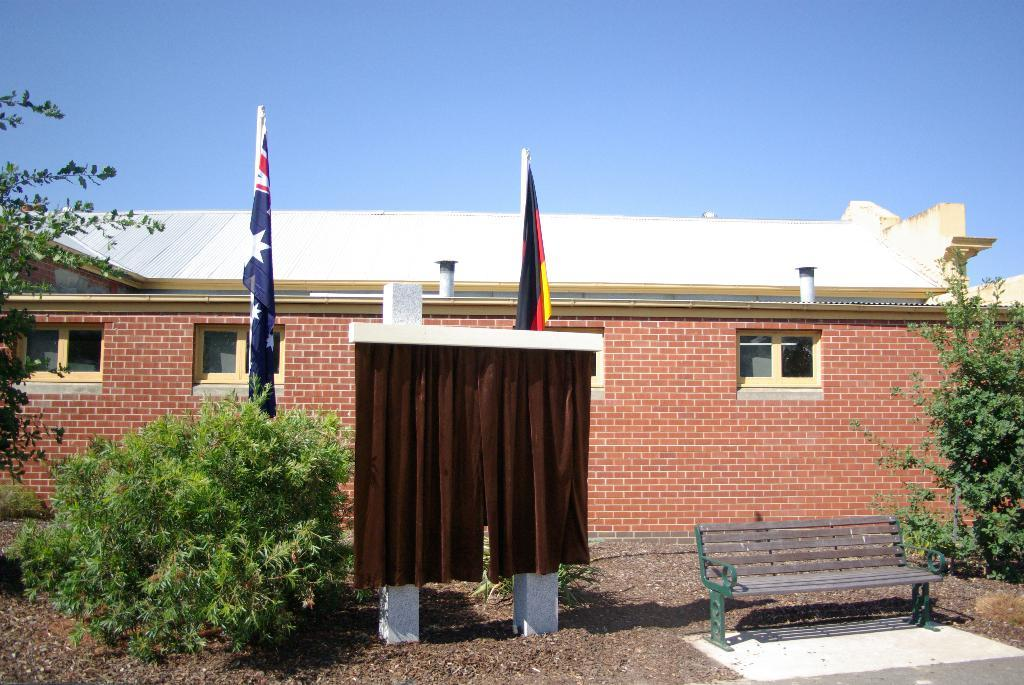What type of structure is depicted in the image? The image contains a building with a roof top. What material is used to construct the walls of the building? The walls of the building are made of bricks. What other elements can be seen in the image besides the building? There are plants, a bench, and flags present in the image. What is the color of the sky in the image? The sky is blue in color. What type of texture can be seen on the cave walls in the image? There is no cave present in the image; it features a building with a roof top and brick walls. How many bells are hanging from the roof of the building in the image? There are no bells visible in the image; it only shows a building, plants, a bench, and flags. 